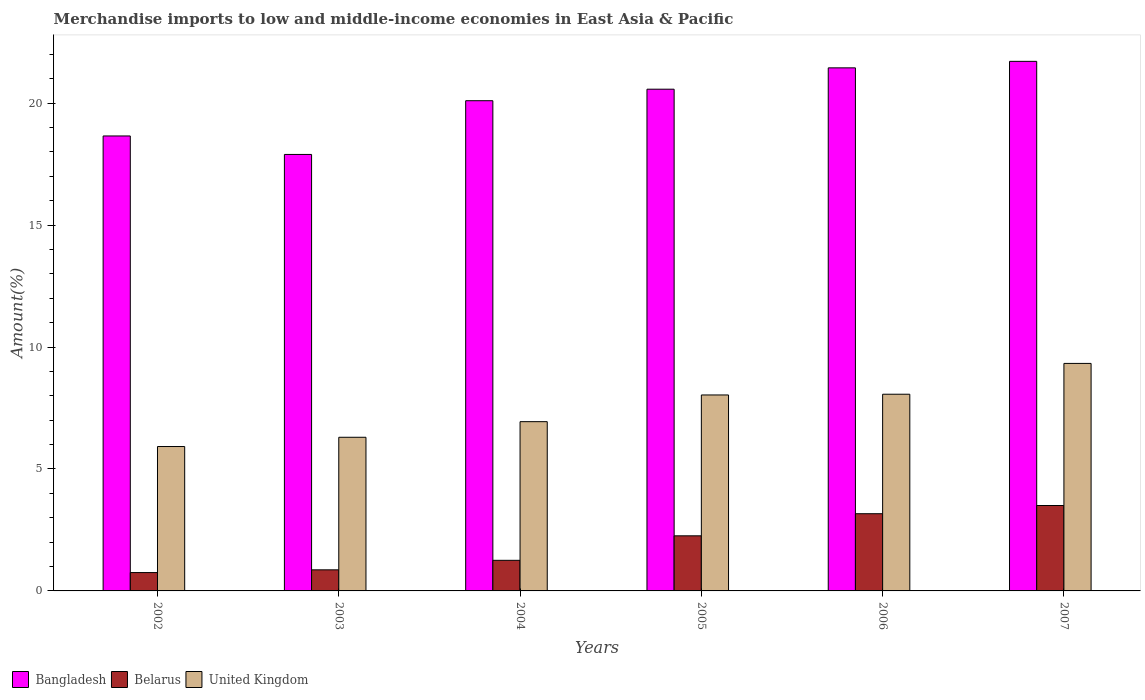How many groups of bars are there?
Provide a short and direct response. 6. Are the number of bars on each tick of the X-axis equal?
Offer a terse response. Yes. What is the label of the 1st group of bars from the left?
Ensure brevity in your answer.  2002. What is the percentage of amount earned from merchandise imports in Bangladesh in 2004?
Give a very brief answer. 20.1. Across all years, what is the maximum percentage of amount earned from merchandise imports in Belarus?
Ensure brevity in your answer.  3.5. Across all years, what is the minimum percentage of amount earned from merchandise imports in Belarus?
Provide a short and direct response. 0.75. What is the total percentage of amount earned from merchandise imports in Bangladesh in the graph?
Give a very brief answer. 120.37. What is the difference between the percentage of amount earned from merchandise imports in Bangladesh in 2006 and that in 2007?
Provide a short and direct response. -0.27. What is the difference between the percentage of amount earned from merchandise imports in United Kingdom in 2006 and the percentage of amount earned from merchandise imports in Bangladesh in 2002?
Keep it short and to the point. -10.59. What is the average percentage of amount earned from merchandise imports in United Kingdom per year?
Provide a succinct answer. 7.43. In the year 2002, what is the difference between the percentage of amount earned from merchandise imports in United Kingdom and percentage of amount earned from merchandise imports in Belarus?
Your answer should be compact. 5.17. In how many years, is the percentage of amount earned from merchandise imports in Belarus greater than 13 %?
Provide a short and direct response. 0. What is the ratio of the percentage of amount earned from merchandise imports in Bangladesh in 2002 to that in 2006?
Provide a succinct answer. 0.87. Is the percentage of amount earned from merchandise imports in United Kingdom in 2004 less than that in 2005?
Offer a terse response. Yes. What is the difference between the highest and the second highest percentage of amount earned from merchandise imports in Bangladesh?
Make the answer very short. 0.27. What is the difference between the highest and the lowest percentage of amount earned from merchandise imports in Belarus?
Provide a succinct answer. 2.75. How many bars are there?
Your answer should be compact. 18. Are all the bars in the graph horizontal?
Provide a succinct answer. No. How many years are there in the graph?
Offer a terse response. 6. Are the values on the major ticks of Y-axis written in scientific E-notation?
Make the answer very short. No. Does the graph contain grids?
Ensure brevity in your answer.  No. What is the title of the graph?
Your response must be concise. Merchandise imports to low and middle-income economies in East Asia & Pacific. Does "Georgia" appear as one of the legend labels in the graph?
Offer a terse response. No. What is the label or title of the X-axis?
Keep it short and to the point. Years. What is the label or title of the Y-axis?
Offer a very short reply. Amount(%). What is the Amount(%) of Bangladesh in 2002?
Offer a terse response. 18.65. What is the Amount(%) in Belarus in 2002?
Make the answer very short. 0.75. What is the Amount(%) of United Kingdom in 2002?
Make the answer very short. 5.92. What is the Amount(%) of Bangladesh in 2003?
Offer a very short reply. 17.89. What is the Amount(%) in Belarus in 2003?
Your response must be concise. 0.86. What is the Amount(%) in United Kingdom in 2003?
Your response must be concise. 6.3. What is the Amount(%) of Bangladesh in 2004?
Make the answer very short. 20.1. What is the Amount(%) of Belarus in 2004?
Offer a terse response. 1.25. What is the Amount(%) in United Kingdom in 2004?
Your response must be concise. 6.94. What is the Amount(%) of Bangladesh in 2005?
Keep it short and to the point. 20.57. What is the Amount(%) of Belarus in 2005?
Your response must be concise. 2.26. What is the Amount(%) of United Kingdom in 2005?
Offer a terse response. 8.03. What is the Amount(%) in Bangladesh in 2006?
Offer a very short reply. 21.44. What is the Amount(%) of Belarus in 2006?
Offer a very short reply. 3.17. What is the Amount(%) in United Kingdom in 2006?
Your answer should be very brief. 8.06. What is the Amount(%) in Bangladesh in 2007?
Your answer should be very brief. 21.71. What is the Amount(%) in Belarus in 2007?
Keep it short and to the point. 3.5. What is the Amount(%) of United Kingdom in 2007?
Keep it short and to the point. 9.33. Across all years, what is the maximum Amount(%) of Bangladesh?
Make the answer very short. 21.71. Across all years, what is the maximum Amount(%) of Belarus?
Your answer should be compact. 3.5. Across all years, what is the maximum Amount(%) in United Kingdom?
Your response must be concise. 9.33. Across all years, what is the minimum Amount(%) of Bangladesh?
Provide a succinct answer. 17.89. Across all years, what is the minimum Amount(%) of Belarus?
Offer a very short reply. 0.75. Across all years, what is the minimum Amount(%) in United Kingdom?
Ensure brevity in your answer.  5.92. What is the total Amount(%) in Bangladesh in the graph?
Your answer should be very brief. 120.37. What is the total Amount(%) in Belarus in the graph?
Ensure brevity in your answer.  11.8. What is the total Amount(%) of United Kingdom in the graph?
Give a very brief answer. 44.58. What is the difference between the Amount(%) in Bangladesh in 2002 and that in 2003?
Give a very brief answer. 0.76. What is the difference between the Amount(%) in Belarus in 2002 and that in 2003?
Ensure brevity in your answer.  -0.11. What is the difference between the Amount(%) of United Kingdom in 2002 and that in 2003?
Give a very brief answer. -0.38. What is the difference between the Amount(%) in Bangladesh in 2002 and that in 2004?
Keep it short and to the point. -1.44. What is the difference between the Amount(%) in Belarus in 2002 and that in 2004?
Your response must be concise. -0.5. What is the difference between the Amount(%) in United Kingdom in 2002 and that in 2004?
Your response must be concise. -1.02. What is the difference between the Amount(%) of Bangladesh in 2002 and that in 2005?
Your response must be concise. -1.92. What is the difference between the Amount(%) in Belarus in 2002 and that in 2005?
Make the answer very short. -1.51. What is the difference between the Amount(%) of United Kingdom in 2002 and that in 2005?
Give a very brief answer. -2.11. What is the difference between the Amount(%) in Bangladesh in 2002 and that in 2006?
Your answer should be very brief. -2.79. What is the difference between the Amount(%) in Belarus in 2002 and that in 2006?
Your answer should be compact. -2.41. What is the difference between the Amount(%) in United Kingdom in 2002 and that in 2006?
Your answer should be compact. -2.14. What is the difference between the Amount(%) in Bangladesh in 2002 and that in 2007?
Offer a very short reply. -3.06. What is the difference between the Amount(%) of Belarus in 2002 and that in 2007?
Keep it short and to the point. -2.75. What is the difference between the Amount(%) of United Kingdom in 2002 and that in 2007?
Provide a succinct answer. -3.41. What is the difference between the Amount(%) of Bangladesh in 2003 and that in 2004?
Keep it short and to the point. -2.2. What is the difference between the Amount(%) of Belarus in 2003 and that in 2004?
Make the answer very short. -0.39. What is the difference between the Amount(%) in United Kingdom in 2003 and that in 2004?
Provide a succinct answer. -0.64. What is the difference between the Amount(%) in Bangladesh in 2003 and that in 2005?
Your answer should be compact. -2.68. What is the difference between the Amount(%) of Belarus in 2003 and that in 2005?
Your answer should be very brief. -1.39. What is the difference between the Amount(%) of United Kingdom in 2003 and that in 2005?
Your answer should be compact. -1.73. What is the difference between the Amount(%) in Bangladesh in 2003 and that in 2006?
Offer a very short reply. -3.55. What is the difference between the Amount(%) of Belarus in 2003 and that in 2006?
Make the answer very short. -2.3. What is the difference between the Amount(%) in United Kingdom in 2003 and that in 2006?
Provide a short and direct response. -1.76. What is the difference between the Amount(%) in Bangladesh in 2003 and that in 2007?
Offer a very short reply. -3.82. What is the difference between the Amount(%) of Belarus in 2003 and that in 2007?
Your answer should be very brief. -2.64. What is the difference between the Amount(%) of United Kingdom in 2003 and that in 2007?
Your response must be concise. -3.03. What is the difference between the Amount(%) in Bangladesh in 2004 and that in 2005?
Offer a very short reply. -0.47. What is the difference between the Amount(%) of Belarus in 2004 and that in 2005?
Your answer should be very brief. -1. What is the difference between the Amount(%) of United Kingdom in 2004 and that in 2005?
Offer a terse response. -1.1. What is the difference between the Amount(%) of Bangladesh in 2004 and that in 2006?
Your answer should be very brief. -1.35. What is the difference between the Amount(%) in Belarus in 2004 and that in 2006?
Keep it short and to the point. -1.91. What is the difference between the Amount(%) in United Kingdom in 2004 and that in 2006?
Provide a short and direct response. -1.12. What is the difference between the Amount(%) of Bangladesh in 2004 and that in 2007?
Give a very brief answer. -1.61. What is the difference between the Amount(%) of Belarus in 2004 and that in 2007?
Offer a very short reply. -2.25. What is the difference between the Amount(%) in United Kingdom in 2004 and that in 2007?
Ensure brevity in your answer.  -2.39. What is the difference between the Amount(%) in Bangladesh in 2005 and that in 2006?
Give a very brief answer. -0.87. What is the difference between the Amount(%) of Belarus in 2005 and that in 2006?
Provide a short and direct response. -0.91. What is the difference between the Amount(%) in United Kingdom in 2005 and that in 2006?
Provide a succinct answer. -0.03. What is the difference between the Amount(%) in Bangladesh in 2005 and that in 2007?
Offer a very short reply. -1.14. What is the difference between the Amount(%) in Belarus in 2005 and that in 2007?
Keep it short and to the point. -1.24. What is the difference between the Amount(%) in United Kingdom in 2005 and that in 2007?
Provide a short and direct response. -1.29. What is the difference between the Amount(%) in Bangladesh in 2006 and that in 2007?
Your answer should be very brief. -0.27. What is the difference between the Amount(%) of Belarus in 2006 and that in 2007?
Offer a very short reply. -0.34. What is the difference between the Amount(%) in United Kingdom in 2006 and that in 2007?
Offer a very short reply. -1.26. What is the difference between the Amount(%) of Bangladesh in 2002 and the Amount(%) of Belarus in 2003?
Ensure brevity in your answer.  17.79. What is the difference between the Amount(%) in Bangladesh in 2002 and the Amount(%) in United Kingdom in 2003?
Make the answer very short. 12.35. What is the difference between the Amount(%) in Belarus in 2002 and the Amount(%) in United Kingdom in 2003?
Ensure brevity in your answer.  -5.55. What is the difference between the Amount(%) of Bangladesh in 2002 and the Amount(%) of Belarus in 2004?
Give a very brief answer. 17.4. What is the difference between the Amount(%) of Bangladesh in 2002 and the Amount(%) of United Kingdom in 2004?
Provide a succinct answer. 11.71. What is the difference between the Amount(%) of Belarus in 2002 and the Amount(%) of United Kingdom in 2004?
Provide a succinct answer. -6.19. What is the difference between the Amount(%) of Bangladesh in 2002 and the Amount(%) of Belarus in 2005?
Ensure brevity in your answer.  16.39. What is the difference between the Amount(%) of Bangladesh in 2002 and the Amount(%) of United Kingdom in 2005?
Provide a succinct answer. 10.62. What is the difference between the Amount(%) in Belarus in 2002 and the Amount(%) in United Kingdom in 2005?
Ensure brevity in your answer.  -7.28. What is the difference between the Amount(%) in Bangladesh in 2002 and the Amount(%) in Belarus in 2006?
Keep it short and to the point. 15.49. What is the difference between the Amount(%) in Bangladesh in 2002 and the Amount(%) in United Kingdom in 2006?
Offer a very short reply. 10.59. What is the difference between the Amount(%) in Belarus in 2002 and the Amount(%) in United Kingdom in 2006?
Ensure brevity in your answer.  -7.31. What is the difference between the Amount(%) in Bangladesh in 2002 and the Amount(%) in Belarus in 2007?
Your answer should be compact. 15.15. What is the difference between the Amount(%) in Bangladesh in 2002 and the Amount(%) in United Kingdom in 2007?
Offer a very short reply. 9.33. What is the difference between the Amount(%) of Belarus in 2002 and the Amount(%) of United Kingdom in 2007?
Make the answer very short. -8.57. What is the difference between the Amount(%) in Bangladesh in 2003 and the Amount(%) in Belarus in 2004?
Your response must be concise. 16.64. What is the difference between the Amount(%) of Bangladesh in 2003 and the Amount(%) of United Kingdom in 2004?
Provide a succinct answer. 10.96. What is the difference between the Amount(%) of Belarus in 2003 and the Amount(%) of United Kingdom in 2004?
Keep it short and to the point. -6.07. What is the difference between the Amount(%) in Bangladesh in 2003 and the Amount(%) in Belarus in 2005?
Offer a very short reply. 15.64. What is the difference between the Amount(%) of Bangladesh in 2003 and the Amount(%) of United Kingdom in 2005?
Make the answer very short. 9.86. What is the difference between the Amount(%) of Belarus in 2003 and the Amount(%) of United Kingdom in 2005?
Your answer should be very brief. -7.17. What is the difference between the Amount(%) of Bangladesh in 2003 and the Amount(%) of Belarus in 2006?
Provide a short and direct response. 14.73. What is the difference between the Amount(%) in Bangladesh in 2003 and the Amount(%) in United Kingdom in 2006?
Keep it short and to the point. 9.83. What is the difference between the Amount(%) of Belarus in 2003 and the Amount(%) of United Kingdom in 2006?
Your response must be concise. -7.2. What is the difference between the Amount(%) of Bangladesh in 2003 and the Amount(%) of Belarus in 2007?
Your answer should be compact. 14.39. What is the difference between the Amount(%) in Bangladesh in 2003 and the Amount(%) in United Kingdom in 2007?
Make the answer very short. 8.57. What is the difference between the Amount(%) of Belarus in 2003 and the Amount(%) of United Kingdom in 2007?
Offer a very short reply. -8.46. What is the difference between the Amount(%) of Bangladesh in 2004 and the Amount(%) of Belarus in 2005?
Keep it short and to the point. 17.84. What is the difference between the Amount(%) of Bangladesh in 2004 and the Amount(%) of United Kingdom in 2005?
Offer a very short reply. 12.06. What is the difference between the Amount(%) in Belarus in 2004 and the Amount(%) in United Kingdom in 2005?
Your answer should be very brief. -6.78. What is the difference between the Amount(%) of Bangladesh in 2004 and the Amount(%) of Belarus in 2006?
Ensure brevity in your answer.  16.93. What is the difference between the Amount(%) in Bangladesh in 2004 and the Amount(%) in United Kingdom in 2006?
Provide a succinct answer. 12.03. What is the difference between the Amount(%) of Belarus in 2004 and the Amount(%) of United Kingdom in 2006?
Ensure brevity in your answer.  -6.81. What is the difference between the Amount(%) of Bangladesh in 2004 and the Amount(%) of Belarus in 2007?
Provide a short and direct response. 16.6. What is the difference between the Amount(%) of Bangladesh in 2004 and the Amount(%) of United Kingdom in 2007?
Provide a short and direct response. 10.77. What is the difference between the Amount(%) of Belarus in 2004 and the Amount(%) of United Kingdom in 2007?
Give a very brief answer. -8.07. What is the difference between the Amount(%) of Bangladesh in 2005 and the Amount(%) of Belarus in 2006?
Provide a succinct answer. 17.4. What is the difference between the Amount(%) in Bangladesh in 2005 and the Amount(%) in United Kingdom in 2006?
Your answer should be compact. 12.51. What is the difference between the Amount(%) in Belarus in 2005 and the Amount(%) in United Kingdom in 2006?
Your answer should be compact. -5.8. What is the difference between the Amount(%) in Bangladesh in 2005 and the Amount(%) in Belarus in 2007?
Your answer should be compact. 17.07. What is the difference between the Amount(%) in Bangladesh in 2005 and the Amount(%) in United Kingdom in 2007?
Offer a very short reply. 11.24. What is the difference between the Amount(%) of Belarus in 2005 and the Amount(%) of United Kingdom in 2007?
Offer a terse response. -7.07. What is the difference between the Amount(%) of Bangladesh in 2006 and the Amount(%) of Belarus in 2007?
Ensure brevity in your answer.  17.94. What is the difference between the Amount(%) of Bangladesh in 2006 and the Amount(%) of United Kingdom in 2007?
Ensure brevity in your answer.  12.12. What is the difference between the Amount(%) of Belarus in 2006 and the Amount(%) of United Kingdom in 2007?
Provide a short and direct response. -6.16. What is the average Amount(%) of Bangladesh per year?
Provide a short and direct response. 20.06. What is the average Amount(%) in Belarus per year?
Keep it short and to the point. 1.97. What is the average Amount(%) in United Kingdom per year?
Offer a very short reply. 7.43. In the year 2002, what is the difference between the Amount(%) of Bangladesh and Amount(%) of Belarus?
Make the answer very short. 17.9. In the year 2002, what is the difference between the Amount(%) of Bangladesh and Amount(%) of United Kingdom?
Make the answer very short. 12.73. In the year 2002, what is the difference between the Amount(%) in Belarus and Amount(%) in United Kingdom?
Keep it short and to the point. -5.17. In the year 2003, what is the difference between the Amount(%) of Bangladesh and Amount(%) of Belarus?
Keep it short and to the point. 17.03. In the year 2003, what is the difference between the Amount(%) in Bangladesh and Amount(%) in United Kingdom?
Offer a terse response. 11.6. In the year 2003, what is the difference between the Amount(%) of Belarus and Amount(%) of United Kingdom?
Offer a very short reply. -5.43. In the year 2004, what is the difference between the Amount(%) of Bangladesh and Amount(%) of Belarus?
Your answer should be compact. 18.84. In the year 2004, what is the difference between the Amount(%) in Bangladesh and Amount(%) in United Kingdom?
Your answer should be compact. 13.16. In the year 2004, what is the difference between the Amount(%) in Belarus and Amount(%) in United Kingdom?
Give a very brief answer. -5.68. In the year 2005, what is the difference between the Amount(%) in Bangladesh and Amount(%) in Belarus?
Offer a very short reply. 18.31. In the year 2005, what is the difference between the Amount(%) in Bangladesh and Amount(%) in United Kingdom?
Your answer should be compact. 12.54. In the year 2005, what is the difference between the Amount(%) in Belarus and Amount(%) in United Kingdom?
Offer a terse response. -5.78. In the year 2006, what is the difference between the Amount(%) of Bangladesh and Amount(%) of Belarus?
Provide a short and direct response. 18.28. In the year 2006, what is the difference between the Amount(%) in Bangladesh and Amount(%) in United Kingdom?
Your answer should be compact. 13.38. In the year 2006, what is the difference between the Amount(%) of Belarus and Amount(%) of United Kingdom?
Make the answer very short. -4.9. In the year 2007, what is the difference between the Amount(%) of Bangladesh and Amount(%) of Belarus?
Your answer should be very brief. 18.21. In the year 2007, what is the difference between the Amount(%) in Bangladesh and Amount(%) in United Kingdom?
Your response must be concise. 12.38. In the year 2007, what is the difference between the Amount(%) in Belarus and Amount(%) in United Kingdom?
Your answer should be very brief. -5.83. What is the ratio of the Amount(%) in Bangladesh in 2002 to that in 2003?
Your answer should be compact. 1.04. What is the ratio of the Amount(%) in Belarus in 2002 to that in 2003?
Ensure brevity in your answer.  0.87. What is the ratio of the Amount(%) in United Kingdom in 2002 to that in 2003?
Ensure brevity in your answer.  0.94. What is the ratio of the Amount(%) in Bangladesh in 2002 to that in 2004?
Your answer should be very brief. 0.93. What is the ratio of the Amount(%) of Belarus in 2002 to that in 2004?
Give a very brief answer. 0.6. What is the ratio of the Amount(%) in United Kingdom in 2002 to that in 2004?
Make the answer very short. 0.85. What is the ratio of the Amount(%) of Bangladesh in 2002 to that in 2005?
Offer a very short reply. 0.91. What is the ratio of the Amount(%) in Belarus in 2002 to that in 2005?
Keep it short and to the point. 0.33. What is the ratio of the Amount(%) in United Kingdom in 2002 to that in 2005?
Your answer should be compact. 0.74. What is the ratio of the Amount(%) in Bangladesh in 2002 to that in 2006?
Your response must be concise. 0.87. What is the ratio of the Amount(%) of Belarus in 2002 to that in 2006?
Your answer should be very brief. 0.24. What is the ratio of the Amount(%) of United Kingdom in 2002 to that in 2006?
Your answer should be compact. 0.73. What is the ratio of the Amount(%) of Bangladesh in 2002 to that in 2007?
Offer a very short reply. 0.86. What is the ratio of the Amount(%) in Belarus in 2002 to that in 2007?
Make the answer very short. 0.21. What is the ratio of the Amount(%) of United Kingdom in 2002 to that in 2007?
Keep it short and to the point. 0.63. What is the ratio of the Amount(%) in Bangladesh in 2003 to that in 2004?
Offer a terse response. 0.89. What is the ratio of the Amount(%) in Belarus in 2003 to that in 2004?
Your response must be concise. 0.69. What is the ratio of the Amount(%) of United Kingdom in 2003 to that in 2004?
Keep it short and to the point. 0.91. What is the ratio of the Amount(%) of Bangladesh in 2003 to that in 2005?
Make the answer very short. 0.87. What is the ratio of the Amount(%) of Belarus in 2003 to that in 2005?
Offer a terse response. 0.38. What is the ratio of the Amount(%) in United Kingdom in 2003 to that in 2005?
Make the answer very short. 0.78. What is the ratio of the Amount(%) in Bangladesh in 2003 to that in 2006?
Provide a short and direct response. 0.83. What is the ratio of the Amount(%) in Belarus in 2003 to that in 2006?
Your response must be concise. 0.27. What is the ratio of the Amount(%) in United Kingdom in 2003 to that in 2006?
Keep it short and to the point. 0.78. What is the ratio of the Amount(%) of Bangladesh in 2003 to that in 2007?
Your answer should be very brief. 0.82. What is the ratio of the Amount(%) of Belarus in 2003 to that in 2007?
Keep it short and to the point. 0.25. What is the ratio of the Amount(%) in United Kingdom in 2003 to that in 2007?
Make the answer very short. 0.68. What is the ratio of the Amount(%) in Belarus in 2004 to that in 2005?
Give a very brief answer. 0.56. What is the ratio of the Amount(%) in United Kingdom in 2004 to that in 2005?
Your response must be concise. 0.86. What is the ratio of the Amount(%) in Bangladesh in 2004 to that in 2006?
Offer a terse response. 0.94. What is the ratio of the Amount(%) of Belarus in 2004 to that in 2006?
Your answer should be compact. 0.4. What is the ratio of the Amount(%) of United Kingdom in 2004 to that in 2006?
Keep it short and to the point. 0.86. What is the ratio of the Amount(%) in Bangladesh in 2004 to that in 2007?
Your response must be concise. 0.93. What is the ratio of the Amount(%) in Belarus in 2004 to that in 2007?
Make the answer very short. 0.36. What is the ratio of the Amount(%) in United Kingdom in 2004 to that in 2007?
Make the answer very short. 0.74. What is the ratio of the Amount(%) in Bangladesh in 2005 to that in 2006?
Make the answer very short. 0.96. What is the ratio of the Amount(%) of Belarus in 2005 to that in 2006?
Give a very brief answer. 0.71. What is the ratio of the Amount(%) of Bangladesh in 2005 to that in 2007?
Your answer should be compact. 0.95. What is the ratio of the Amount(%) in Belarus in 2005 to that in 2007?
Provide a succinct answer. 0.65. What is the ratio of the Amount(%) of United Kingdom in 2005 to that in 2007?
Your answer should be compact. 0.86. What is the ratio of the Amount(%) in Bangladesh in 2006 to that in 2007?
Your response must be concise. 0.99. What is the ratio of the Amount(%) in Belarus in 2006 to that in 2007?
Give a very brief answer. 0.9. What is the ratio of the Amount(%) in United Kingdom in 2006 to that in 2007?
Your answer should be compact. 0.86. What is the difference between the highest and the second highest Amount(%) of Bangladesh?
Offer a very short reply. 0.27. What is the difference between the highest and the second highest Amount(%) of Belarus?
Your response must be concise. 0.34. What is the difference between the highest and the second highest Amount(%) of United Kingdom?
Ensure brevity in your answer.  1.26. What is the difference between the highest and the lowest Amount(%) in Bangladesh?
Give a very brief answer. 3.82. What is the difference between the highest and the lowest Amount(%) of Belarus?
Ensure brevity in your answer.  2.75. What is the difference between the highest and the lowest Amount(%) in United Kingdom?
Give a very brief answer. 3.41. 